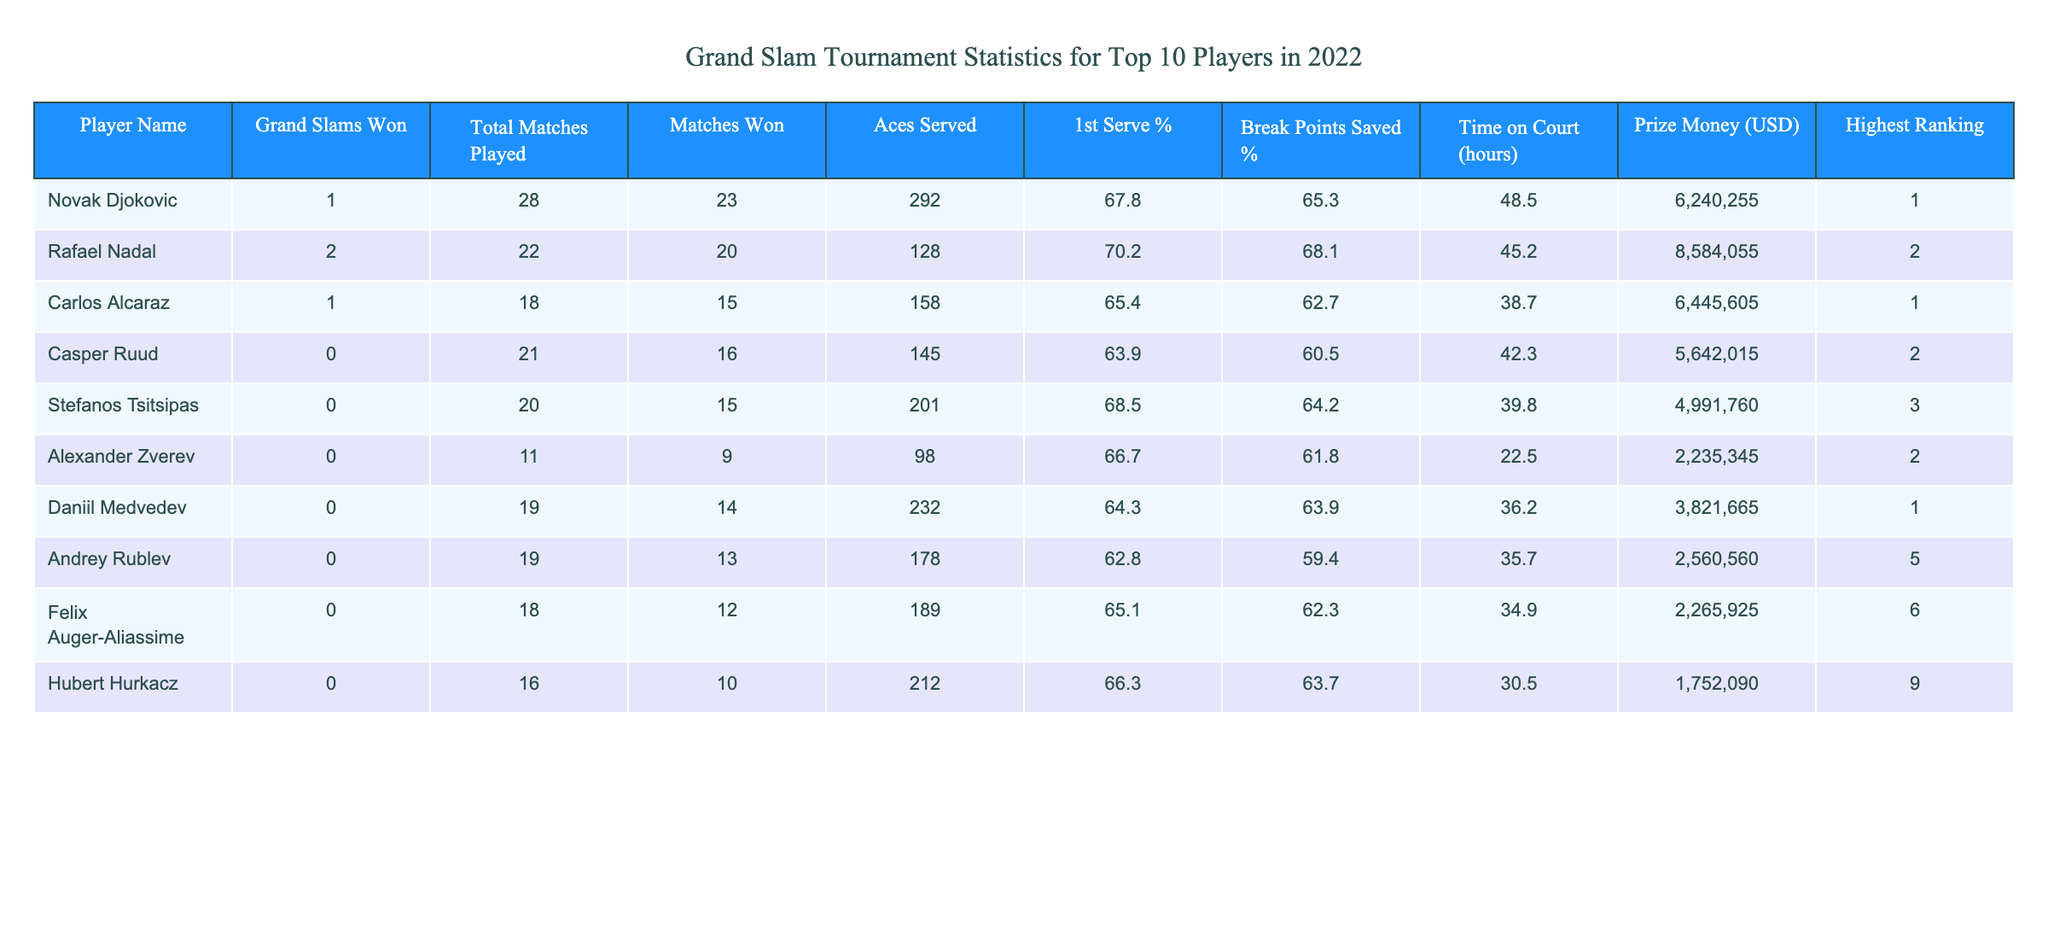What is the highest number of Grand Slams won by a player in 2022? The table shows that Rafael Nadal won 2 Grand Slams, which is the highest number compared to other players listed.
Answer: 2 Which player had the most matches played in 2022? From the table, we see that Novak Djokovic played the most matches, with a total of 28 matches.
Answer: 28 What is the average number of Aces served by players who won Grand Slams? The players who won Grand Slams are Novak Djokovic and Rafael Nadal (1 and 2 Aces respectively). Their total Aces served is 292 + 128 = 420. There are 2 players, so the average is 420/2 = 210.
Answer: 210 Did any player save more than 70% of break points in 2022? By checking the "Break Points Saved %" column, only Rafael Nadal has a percentage of 68.1, which is less than 70%. Therefore, no player saved more than 70%.
Answer: No What is the total prize money earned by the players who did not win any Grand Slams? The total prize money for players who did not win Grand Slams (Casper Ruud, Stefanos Tsitsipas, Alexander Zverev, Daniil Medvedev, Andrey Rublev, Felix Auger-Aliassime, and Hubert Hurkacz) is: 5642015 + 4991760 + 2235345 + 3821665 + 2560560 + 2265925 + 1752090 = 18828300 USD.
Answer: 18828300 Which player had the lowest 1st serve percentage among the top players? The table indicates that Andrey Rublev had the lowest 1st serve percentage at 62.8%.
Answer: 62.8% How does the total matches won compare between players who won Grand Slams and those who didn't? Players who won Grand Slams (Djokovic, Nadal, Alcaraz) had a total of 23 + 20 + 15 = 58 matches won. The total for players who didn't win any Grand Slams (Ruud, Tsitsipas, Zverev, Medvedev, Rublev, Auger-Aliassime, Hurkacz) is 16 + 15 + 9 + 14 + 13 + 12 + 10 = 99. Comparing both results, players who didn't win had more matches won.
Answer: Players who didn't win had more matches won What is the relationship between Aces served and Prize Money earned for players who won Grand Slams? Novak Djokovic served 292 Aces and earned 6240255 USD, while Rafael Nadal served 128 Aces and earned 8584055 USD. The relationship suggests that Djokovic served more Aces but earned less in comparison due to lower Grand Slam wins.
Answer: Djokovic served more but earned less How many hours did Rafael Nadal spend on court in 2022 compared to Alexander Zverev? Rafael Nadal spent 45.2 hours on the court, while Alexander Zverev spent only 22.5 hours. Thus, Nadal spent 45.2 - 22.5 = 22.7 more hours on court than Zverev.
Answer: 22.7 more hours 